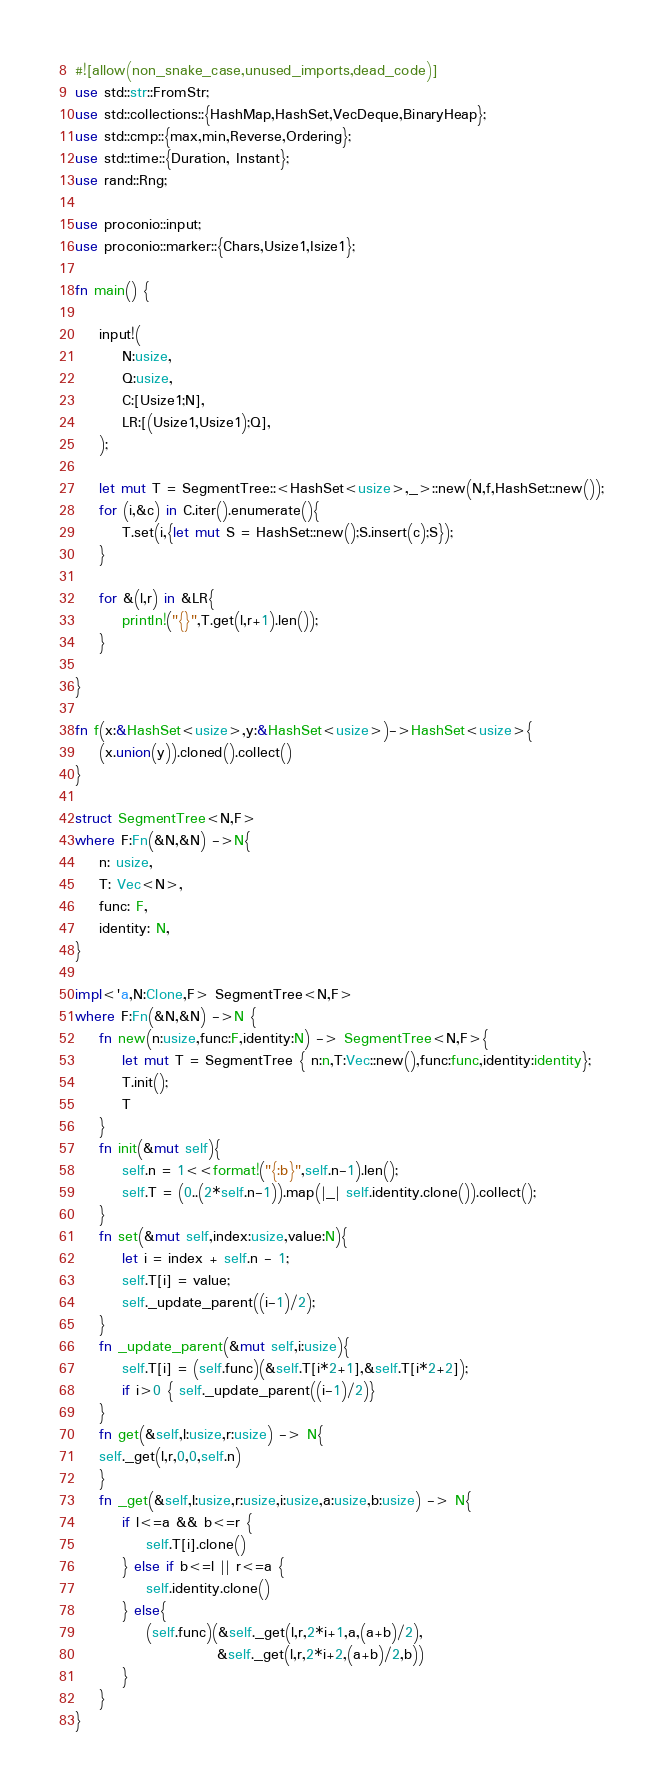Convert code to text. <code><loc_0><loc_0><loc_500><loc_500><_Rust_>#![allow(non_snake_case,unused_imports,dead_code)]
use std::str::FromStr;
use std::collections::{HashMap,HashSet,VecDeque,BinaryHeap};
use std::cmp::{max,min,Reverse,Ordering};
use std::time::{Duration, Instant};
use rand::Rng;

use proconio::input;
use proconio::marker::{Chars,Usize1,Isize1};

fn main() {

    input!(
        N:usize,
        Q:usize,
        C:[Usize1;N],
        LR:[(Usize1,Usize1);Q],
    );

    let mut T = SegmentTree::<HashSet<usize>,_>::new(N,f,HashSet::new());
    for (i,&c) in C.iter().enumerate(){
        T.set(i,{let mut S = HashSet::new();S.insert(c);S});
    }

    for &(l,r) in &LR{
        println!("{}",T.get(l,r+1).len());
    }

}

fn f(x:&HashSet<usize>,y:&HashSet<usize>)->HashSet<usize>{
    (x.union(y)).cloned().collect()
}

struct SegmentTree<N,F>
where F:Fn(&N,&N) ->N{
    n: usize,
    T: Vec<N>,
    func: F,
    identity: N,
}

impl<'a,N:Clone,F> SegmentTree<N,F>
where F:Fn(&N,&N) ->N {
    fn new(n:usize,func:F,identity:N) -> SegmentTree<N,F>{
        let mut T = SegmentTree { n:n,T:Vec::new(),func:func,identity:identity};
        T.init();
        T
    }
    fn init(&mut self){
        self.n = 1<<format!("{:b}",self.n-1).len();
        self.T = (0..(2*self.n-1)).map(|_| self.identity.clone()).collect();
    }
    fn set(&mut self,index:usize,value:N){
        let i = index + self.n - 1;
        self.T[i] = value;
        self._update_parent((i-1)/2);
    }
    fn _update_parent(&mut self,i:usize){
        self.T[i] = (self.func)(&self.T[i*2+1],&self.T[i*2+2]);
        if i>0 { self._update_parent((i-1)/2)}
    }
    fn get(&self,l:usize,r:usize) -> N{
    self._get(l,r,0,0,self.n)
    }
    fn _get(&self,l:usize,r:usize,i:usize,a:usize,b:usize) -> N{
        if l<=a && b<=r {
            self.T[i].clone()
        } else if b<=l || r<=a {
            self.identity.clone()
        } else{
            (self.func)(&self._get(l,r,2*i+1,a,(a+b)/2),
                        &self._get(l,r,2*i+2,(a+b)/2,b))
        }
    }
}</code> 